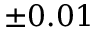Convert formula to latex. <formula><loc_0><loc_0><loc_500><loc_500>\pm 0 . 0 1</formula> 